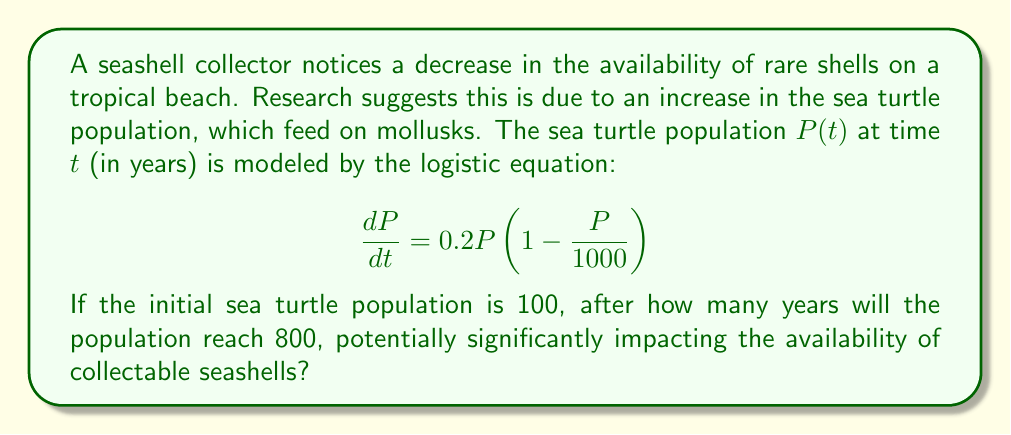What is the answer to this math problem? To solve this problem, we'll use the analytical solution of the logistic equation and follow these steps:

1) The general solution to the logistic equation is:

   $$P(t) = \frac{K}{1 + \left(\frac{K}{P_0} - 1\right)e^{-rt}}$$

   where $K$ is the carrying capacity, $P_0$ is the initial population, and $r$ is the growth rate.

2) From the given equation, we can identify:
   $K = 1000$ (carrying capacity)
   $r = 0.2$ (growth rate)
   $P_0 = 100$ (initial population)

3) We want to find $t$ when $P(t) = 800$. Substituting these values into the equation:

   $$800 = \frac{1000}{1 + \left(\frac{1000}{100} - 1\right)e^{-0.2t}}$$

4) Simplify:
   $$800 = \frac{1000}{1 + 9e^{-0.2t}}$$

5) Multiply both sides by $(1 + 9e^{-0.2t})$:
   $$800 + 7200e^{-0.2t} = 1000$$

6) Subtract 800 from both sides:
   $$7200e^{-0.2t} = 200$$

7) Divide both sides by 7200:
   $$e^{-0.2t} = \frac{1}{36}$$

8) Take the natural log of both sides:
   $$-0.2t = \ln\left(\frac{1}{36}\right) = -\ln(36)$$

9) Divide both sides by -0.2:
   $$t = \frac{\ln(36)}{0.2} \approx 17.97$$

The population will reach 800 after approximately 17.97 years.
Answer: 17.97 years 